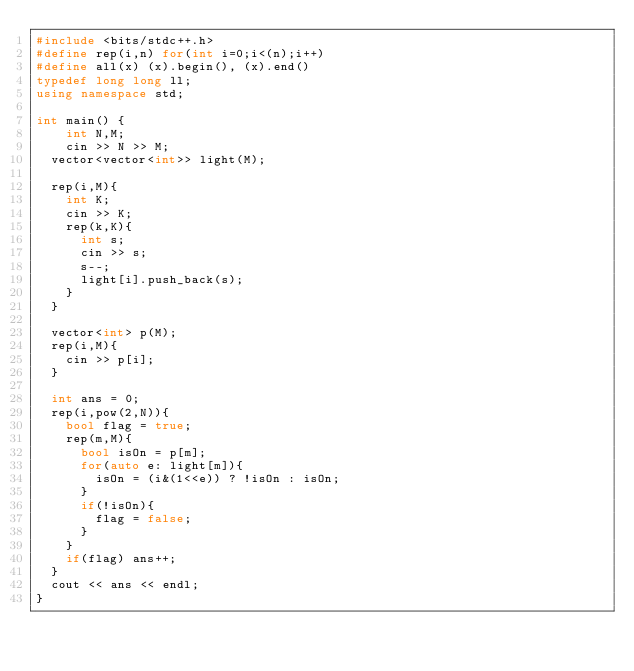<code> <loc_0><loc_0><loc_500><loc_500><_C++_>#include <bits/stdc++.h>
#define rep(i,n) for(int i=0;i<(n);i++) 
#define all(x) (x).begin(), (x).end()
typedef long long ll;
using namespace std;

int main() {
	int N,M;
	cin >> N >> M;
  vector<vector<int>> light(M);
  
  rep(i,M){
    int K;
    cin >> K;
    rep(k,K){
      int s;
      cin >> s;
      s--;
      light[i].push_back(s);
    }
  }

  vector<int> p(M);
  rep(i,M){
    cin >> p[i];
  }

  int ans = 0;
  rep(i,pow(2,N)){
    bool flag = true;
    rep(m,M){
      bool isOn = p[m];
      for(auto e: light[m]){
        isOn = (i&(1<<e)) ? !isOn : isOn;
      }
      if(!isOn){
        flag = false;
      }
    }
    if(flag) ans++;
  }
  cout << ans << endl;
}</code> 